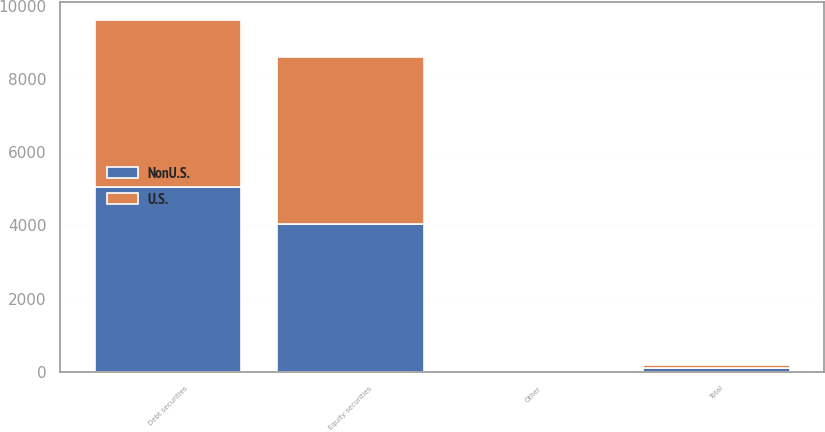Convert chart. <chart><loc_0><loc_0><loc_500><loc_500><stacked_bar_chart><ecel><fcel>Equity securities<fcel>Debt securities<fcel>Other<fcel>Total<nl><fcel>U.S.<fcel>4555<fcel>4555<fcel>5<fcel>100<nl><fcel>NonU.S.<fcel>4050<fcel>5060<fcel>5<fcel>100<nl></chart> 